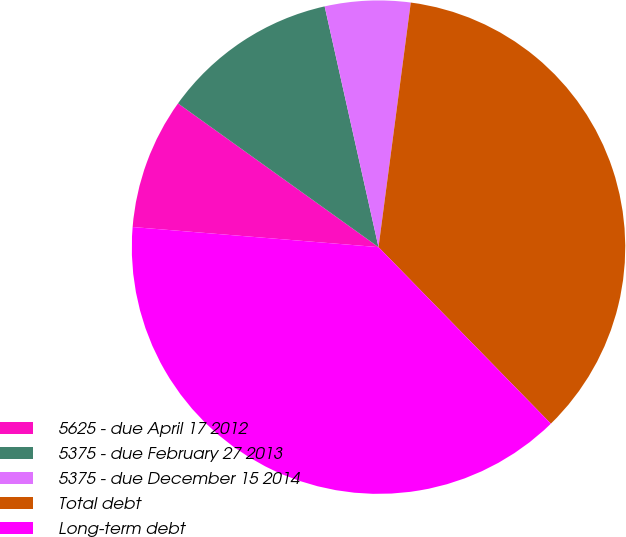Convert chart to OTSL. <chart><loc_0><loc_0><loc_500><loc_500><pie_chart><fcel>5625 - due April 17 2012<fcel>5375 - due February 27 2013<fcel>5375 - due December 15 2014<fcel>Total debt<fcel>Long-term debt<nl><fcel>8.6%<fcel>11.6%<fcel>5.59%<fcel>35.61%<fcel>38.61%<nl></chart> 